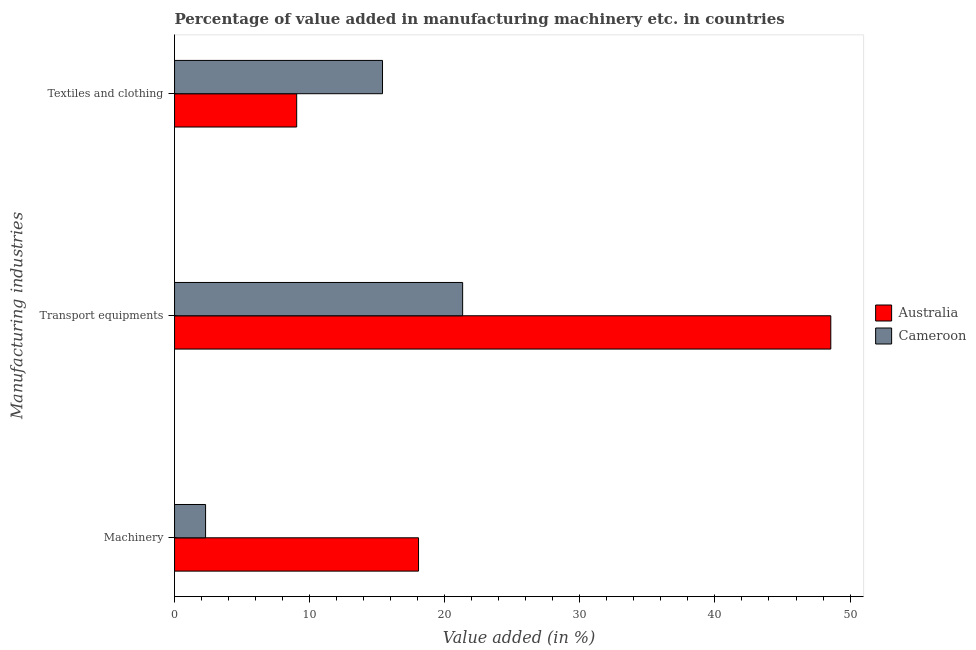How many different coloured bars are there?
Offer a very short reply. 2. Are the number of bars on each tick of the Y-axis equal?
Make the answer very short. Yes. How many bars are there on the 1st tick from the bottom?
Give a very brief answer. 2. What is the label of the 1st group of bars from the top?
Your response must be concise. Textiles and clothing. What is the value added in manufacturing machinery in Cameroon?
Offer a very short reply. 2.3. Across all countries, what is the maximum value added in manufacturing machinery?
Give a very brief answer. 18.06. Across all countries, what is the minimum value added in manufacturing textile and clothing?
Make the answer very short. 9.04. In which country was the value added in manufacturing textile and clothing maximum?
Make the answer very short. Cameroon. What is the total value added in manufacturing machinery in the graph?
Provide a short and direct response. 20.36. What is the difference between the value added in manufacturing textile and clothing in Australia and that in Cameroon?
Provide a short and direct response. -6.35. What is the difference between the value added in manufacturing textile and clothing in Australia and the value added in manufacturing transport equipments in Cameroon?
Provide a short and direct response. -12.28. What is the average value added in manufacturing textile and clothing per country?
Ensure brevity in your answer.  12.22. What is the difference between the value added in manufacturing machinery and value added in manufacturing textile and clothing in Cameroon?
Offer a terse response. -13.1. In how many countries, is the value added in manufacturing textile and clothing greater than 26 %?
Ensure brevity in your answer.  0. What is the ratio of the value added in manufacturing machinery in Cameroon to that in Australia?
Offer a very short reply. 0.13. Is the difference between the value added in manufacturing machinery in Cameroon and Australia greater than the difference between the value added in manufacturing transport equipments in Cameroon and Australia?
Offer a very short reply. Yes. What is the difference between the highest and the second highest value added in manufacturing transport equipments?
Offer a very short reply. 27.25. What is the difference between the highest and the lowest value added in manufacturing machinery?
Your answer should be very brief. 15.76. In how many countries, is the value added in manufacturing textile and clothing greater than the average value added in manufacturing textile and clothing taken over all countries?
Your answer should be very brief. 1. What does the 1st bar from the top in Textiles and clothing represents?
Offer a very short reply. Cameroon. What does the 2nd bar from the bottom in Transport equipments represents?
Offer a terse response. Cameroon. Is it the case that in every country, the sum of the value added in manufacturing machinery and value added in manufacturing transport equipments is greater than the value added in manufacturing textile and clothing?
Your answer should be very brief. Yes. Are all the bars in the graph horizontal?
Ensure brevity in your answer.  Yes. Does the graph contain any zero values?
Your response must be concise. No. How are the legend labels stacked?
Give a very brief answer. Vertical. What is the title of the graph?
Provide a short and direct response. Percentage of value added in manufacturing machinery etc. in countries. What is the label or title of the X-axis?
Keep it short and to the point. Value added (in %). What is the label or title of the Y-axis?
Ensure brevity in your answer.  Manufacturing industries. What is the Value added (in %) in Australia in Machinery?
Your answer should be compact. 18.06. What is the Value added (in %) of Cameroon in Machinery?
Keep it short and to the point. 2.3. What is the Value added (in %) of Australia in Transport equipments?
Give a very brief answer. 48.58. What is the Value added (in %) of Cameroon in Transport equipments?
Keep it short and to the point. 21.32. What is the Value added (in %) of Australia in Textiles and clothing?
Provide a short and direct response. 9.04. What is the Value added (in %) in Cameroon in Textiles and clothing?
Keep it short and to the point. 15.39. Across all Manufacturing industries, what is the maximum Value added (in %) of Australia?
Your response must be concise. 48.58. Across all Manufacturing industries, what is the maximum Value added (in %) of Cameroon?
Give a very brief answer. 21.32. Across all Manufacturing industries, what is the minimum Value added (in %) of Australia?
Provide a short and direct response. 9.04. Across all Manufacturing industries, what is the minimum Value added (in %) of Cameroon?
Give a very brief answer. 2.3. What is the total Value added (in %) of Australia in the graph?
Keep it short and to the point. 75.68. What is the total Value added (in %) of Cameroon in the graph?
Offer a very short reply. 39.01. What is the difference between the Value added (in %) in Australia in Machinery and that in Transport equipments?
Keep it short and to the point. -30.52. What is the difference between the Value added (in %) of Cameroon in Machinery and that in Transport equipments?
Provide a succinct answer. -19.03. What is the difference between the Value added (in %) of Australia in Machinery and that in Textiles and clothing?
Make the answer very short. 9.02. What is the difference between the Value added (in %) in Cameroon in Machinery and that in Textiles and clothing?
Your answer should be very brief. -13.1. What is the difference between the Value added (in %) in Australia in Transport equipments and that in Textiles and clothing?
Give a very brief answer. 39.54. What is the difference between the Value added (in %) in Cameroon in Transport equipments and that in Textiles and clothing?
Your answer should be very brief. 5.93. What is the difference between the Value added (in %) in Australia in Machinery and the Value added (in %) in Cameroon in Transport equipments?
Keep it short and to the point. -3.26. What is the difference between the Value added (in %) in Australia in Machinery and the Value added (in %) in Cameroon in Textiles and clothing?
Your answer should be compact. 2.67. What is the difference between the Value added (in %) of Australia in Transport equipments and the Value added (in %) of Cameroon in Textiles and clothing?
Keep it short and to the point. 33.18. What is the average Value added (in %) in Australia per Manufacturing industries?
Your answer should be very brief. 25.23. What is the average Value added (in %) in Cameroon per Manufacturing industries?
Your answer should be very brief. 13. What is the difference between the Value added (in %) in Australia and Value added (in %) in Cameroon in Machinery?
Your answer should be very brief. 15.76. What is the difference between the Value added (in %) in Australia and Value added (in %) in Cameroon in Transport equipments?
Make the answer very short. 27.25. What is the difference between the Value added (in %) in Australia and Value added (in %) in Cameroon in Textiles and clothing?
Provide a succinct answer. -6.35. What is the ratio of the Value added (in %) of Australia in Machinery to that in Transport equipments?
Offer a very short reply. 0.37. What is the ratio of the Value added (in %) in Cameroon in Machinery to that in Transport equipments?
Keep it short and to the point. 0.11. What is the ratio of the Value added (in %) of Australia in Machinery to that in Textiles and clothing?
Your answer should be very brief. 2. What is the ratio of the Value added (in %) in Cameroon in Machinery to that in Textiles and clothing?
Ensure brevity in your answer.  0.15. What is the ratio of the Value added (in %) in Australia in Transport equipments to that in Textiles and clothing?
Provide a succinct answer. 5.37. What is the ratio of the Value added (in %) in Cameroon in Transport equipments to that in Textiles and clothing?
Offer a very short reply. 1.39. What is the difference between the highest and the second highest Value added (in %) of Australia?
Your answer should be very brief. 30.52. What is the difference between the highest and the second highest Value added (in %) of Cameroon?
Your answer should be very brief. 5.93. What is the difference between the highest and the lowest Value added (in %) in Australia?
Give a very brief answer. 39.54. What is the difference between the highest and the lowest Value added (in %) in Cameroon?
Keep it short and to the point. 19.03. 